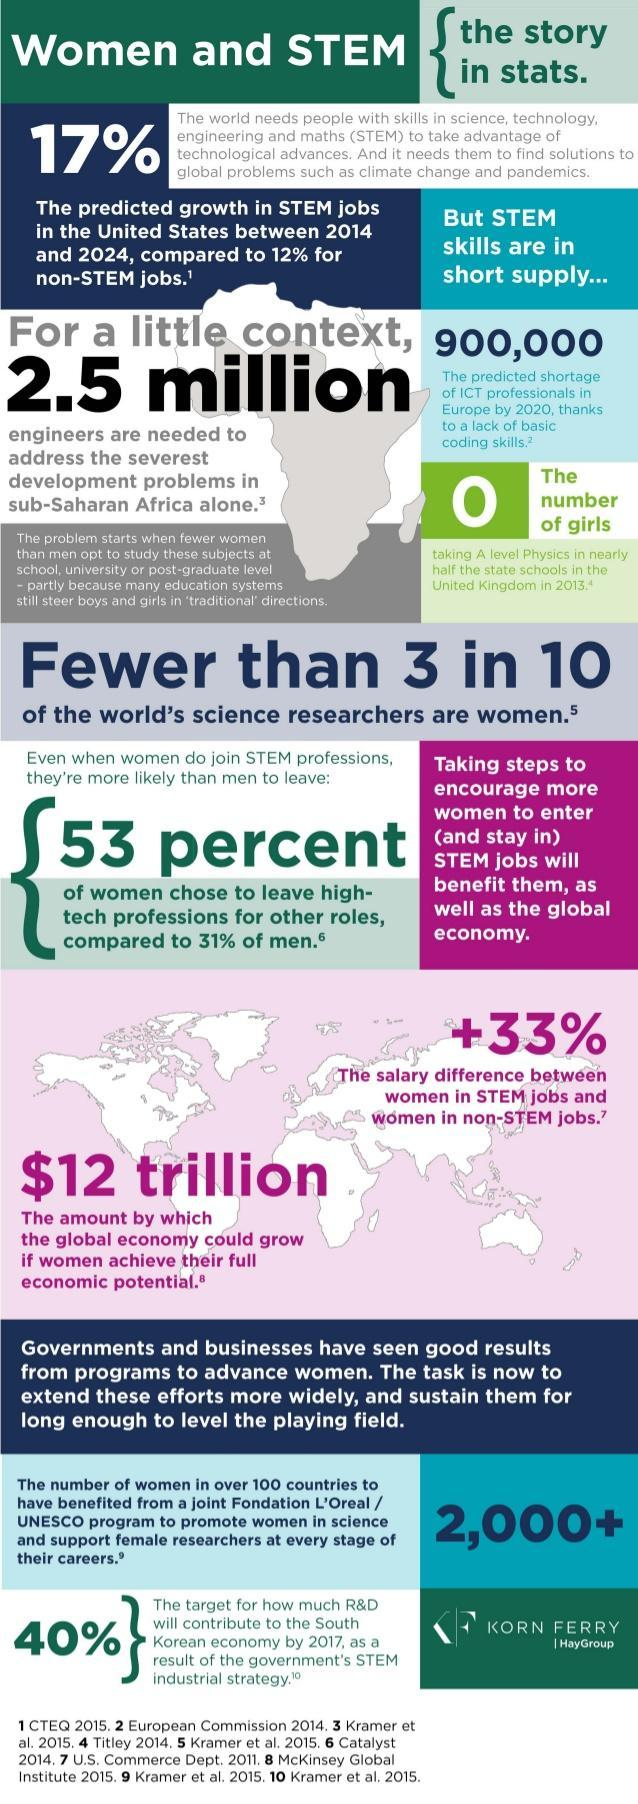what is the predicted shortage of ICT professionals in Europe by 2020
Answer the question with a short phrase. 900,000 how many women in over 100 countries will benefit from a joint Fondation L'Oreal / UNESCO program 2,000+ 